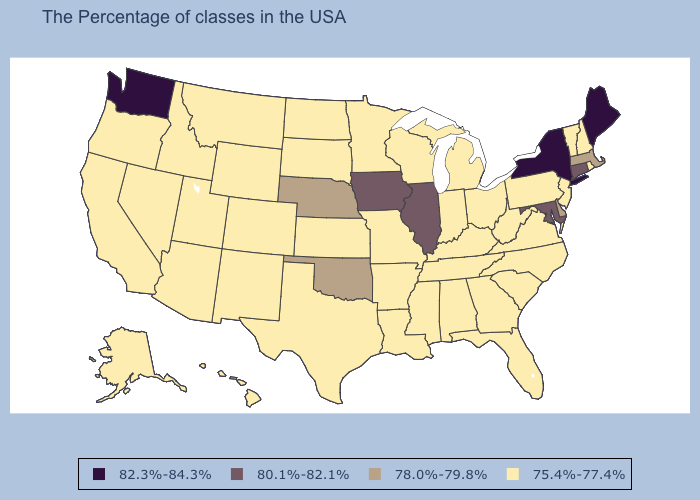What is the highest value in states that border Texas?
Quick response, please. 78.0%-79.8%. Does Delaware have a lower value than Maryland?
Give a very brief answer. Yes. What is the value of Oklahoma?
Concise answer only. 78.0%-79.8%. What is the highest value in states that border Mississippi?
Write a very short answer. 75.4%-77.4%. What is the value of Montana?
Quick response, please. 75.4%-77.4%. Does Hawaii have a higher value than New Jersey?
Concise answer only. No. Is the legend a continuous bar?
Keep it brief. No. How many symbols are there in the legend?
Quick response, please. 4. What is the value of Kentucky?
Be succinct. 75.4%-77.4%. Name the states that have a value in the range 75.4%-77.4%?
Short answer required. Rhode Island, New Hampshire, Vermont, New Jersey, Pennsylvania, Virginia, North Carolina, South Carolina, West Virginia, Ohio, Florida, Georgia, Michigan, Kentucky, Indiana, Alabama, Tennessee, Wisconsin, Mississippi, Louisiana, Missouri, Arkansas, Minnesota, Kansas, Texas, South Dakota, North Dakota, Wyoming, Colorado, New Mexico, Utah, Montana, Arizona, Idaho, Nevada, California, Oregon, Alaska, Hawaii. Name the states that have a value in the range 80.1%-82.1%?
Keep it brief. Connecticut, Maryland, Illinois, Iowa. Does Mississippi have the highest value in the USA?
Quick response, please. No. Among the states that border Tennessee , which have the highest value?
Answer briefly. Virginia, North Carolina, Georgia, Kentucky, Alabama, Mississippi, Missouri, Arkansas. Which states hav the highest value in the West?
Be succinct. Washington. Does Delaware have a lower value than Illinois?
Short answer required. Yes. 